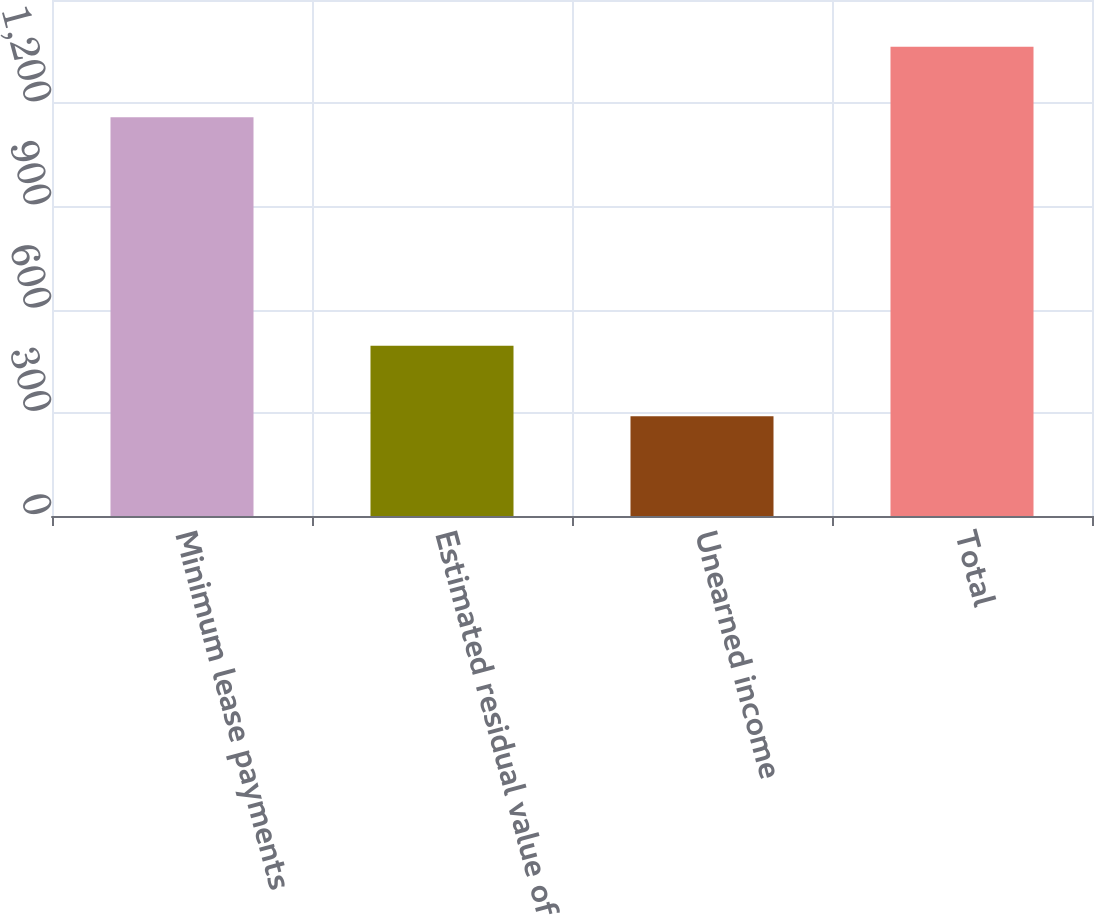<chart> <loc_0><loc_0><loc_500><loc_500><bar_chart><fcel>Minimum lease payments<fcel>Estimated residual value of<fcel>Unearned income<fcel>Total<nl><fcel>1159<fcel>495<fcel>290<fcel>1364<nl></chart> 